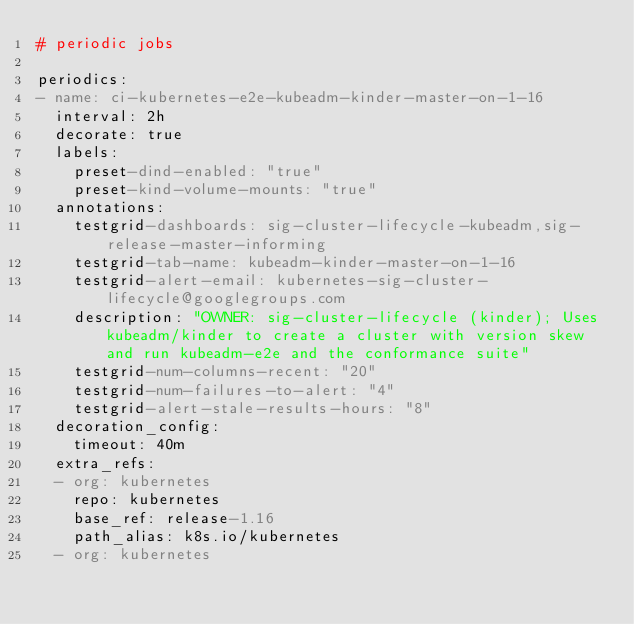Convert code to text. <code><loc_0><loc_0><loc_500><loc_500><_YAML_># periodic jobs

periodics:
- name: ci-kubernetes-e2e-kubeadm-kinder-master-on-1-16
  interval: 2h
  decorate: true
  labels:
    preset-dind-enabled: "true"
    preset-kind-volume-mounts: "true"
  annotations:
    testgrid-dashboards: sig-cluster-lifecycle-kubeadm,sig-release-master-informing
    testgrid-tab-name: kubeadm-kinder-master-on-1-16
    testgrid-alert-email: kubernetes-sig-cluster-lifecycle@googlegroups.com
    description: "OWNER: sig-cluster-lifecycle (kinder); Uses kubeadm/kinder to create a cluster with version skew and run kubeadm-e2e and the conformance suite"
    testgrid-num-columns-recent: "20"
    testgrid-num-failures-to-alert: "4"
    testgrid-alert-stale-results-hours: "8"
  decoration_config:
    timeout: 40m
  extra_refs:
  - org: kubernetes
    repo: kubernetes
    base_ref: release-1.16
    path_alias: k8s.io/kubernetes
  - org: kubernetes</code> 